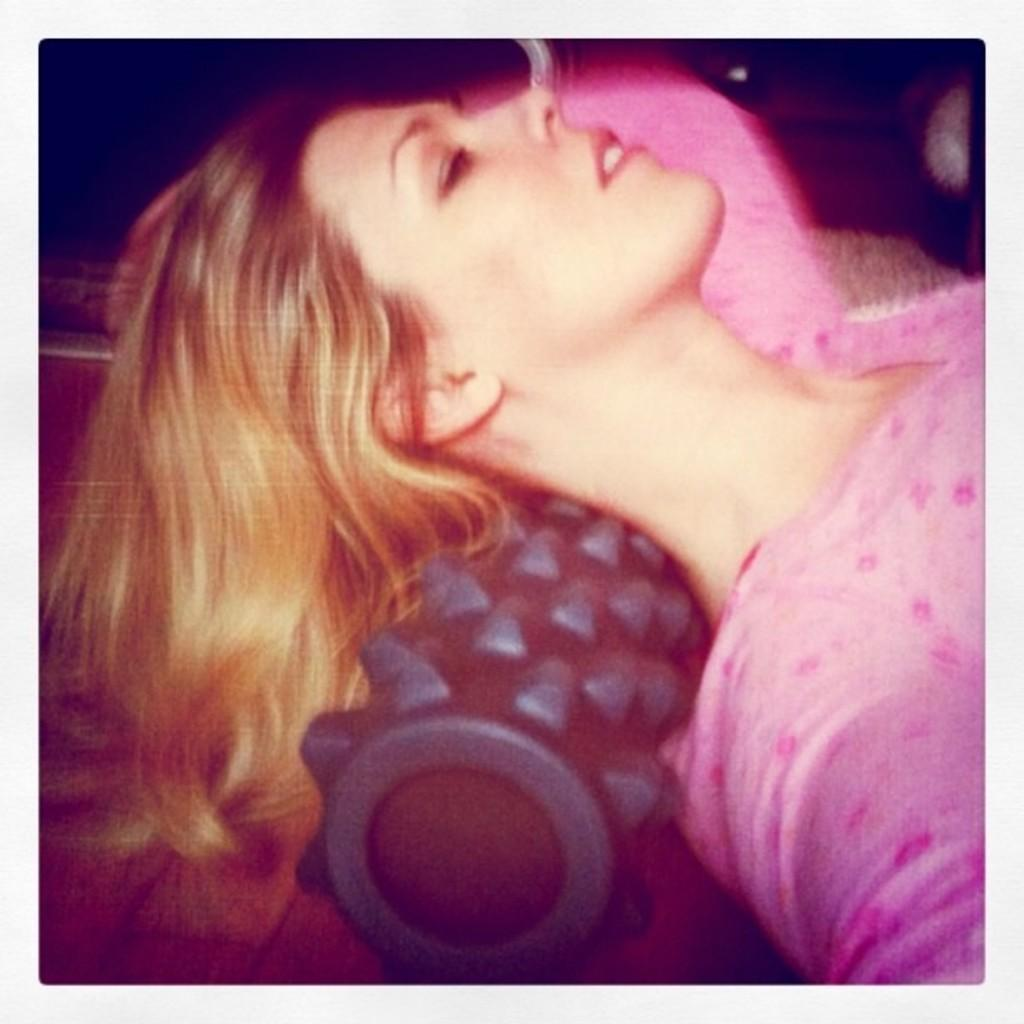Who is the main subject in the image? There is a woman in the image. What is the woman doing in the image? The woman is lying on a roller. What type of question can be seen in the cemetery in the image? There is no cemetery or question present in the image; it features a woman lying on a rolleroller. 